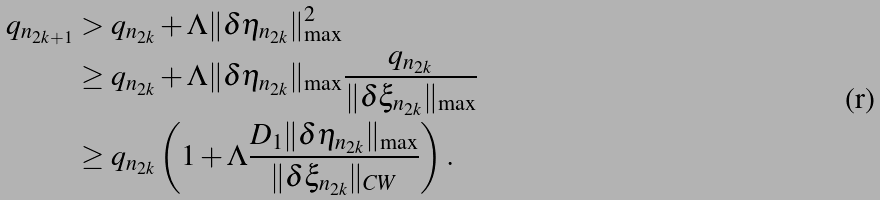<formula> <loc_0><loc_0><loc_500><loc_500>q _ { n _ { 2 k + 1 } } & > q _ { n _ { 2 k } } + \Lambda \| \delta \eta _ { n _ { 2 k } } \| _ { \max } ^ { 2 } \\ & \geq q _ { n _ { 2 k } } + \Lambda \| \delta \eta _ { n _ { 2 k } } \| _ { \max } \frac { q _ { n _ { 2 k } } } { \| \delta \xi _ { n _ { 2 k } } \| _ { \max } } \\ & \geq q _ { n _ { 2 k } } \left ( 1 + \Lambda \frac { D _ { 1 } \| \delta \eta _ { n _ { 2 k } } \| _ { \max } } { \| \delta \xi _ { n _ { 2 k } } \| _ { C W } } \right ) .</formula> 